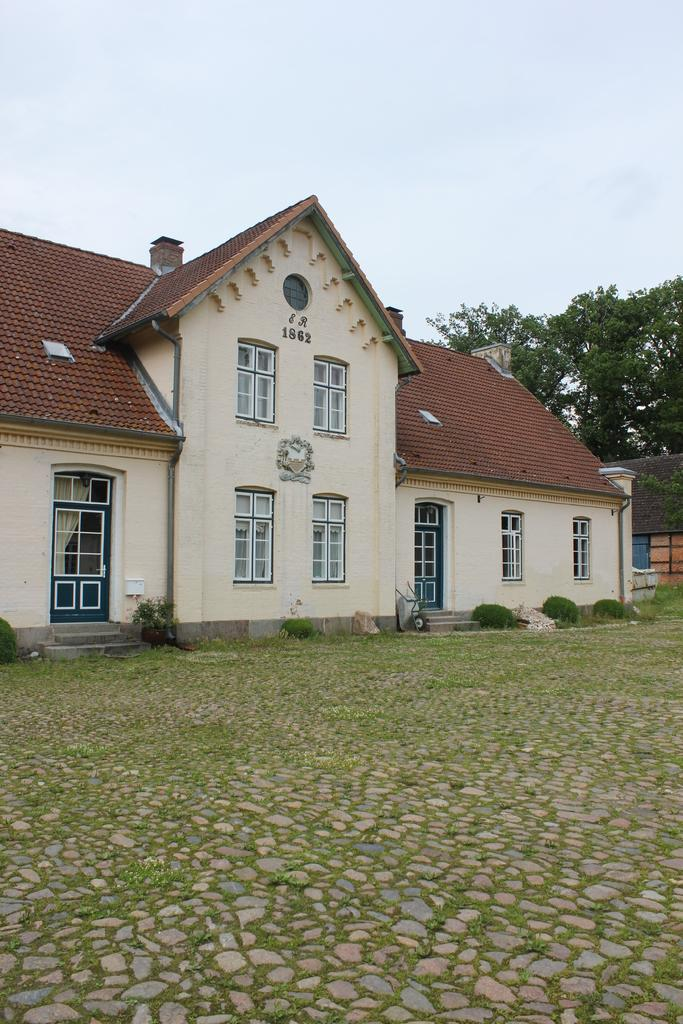What type of surface can be seen in the image? Ground is visible in the image. What type of vegetation is present in the image? There is grass and plants in the image. What type of structure is in the image? There is a house in the image. What features can be seen on the house? The house has a rooftop, windows, and doors. What can be seen in the background of the image? Leaves and the sky are visible in the background of the image. What is there is a tendency for the leaves to change color in the image? There is no mention of the leaves changing color in the image. The leaves are simply visible in the background. 